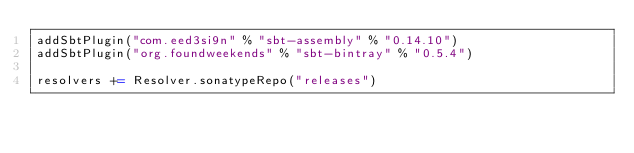<code> <loc_0><loc_0><loc_500><loc_500><_Scala_>addSbtPlugin("com.eed3si9n" % "sbt-assembly" % "0.14.10")
addSbtPlugin("org.foundweekends" % "sbt-bintray" % "0.5.4")

resolvers += Resolver.sonatypeRepo("releases")
</code> 